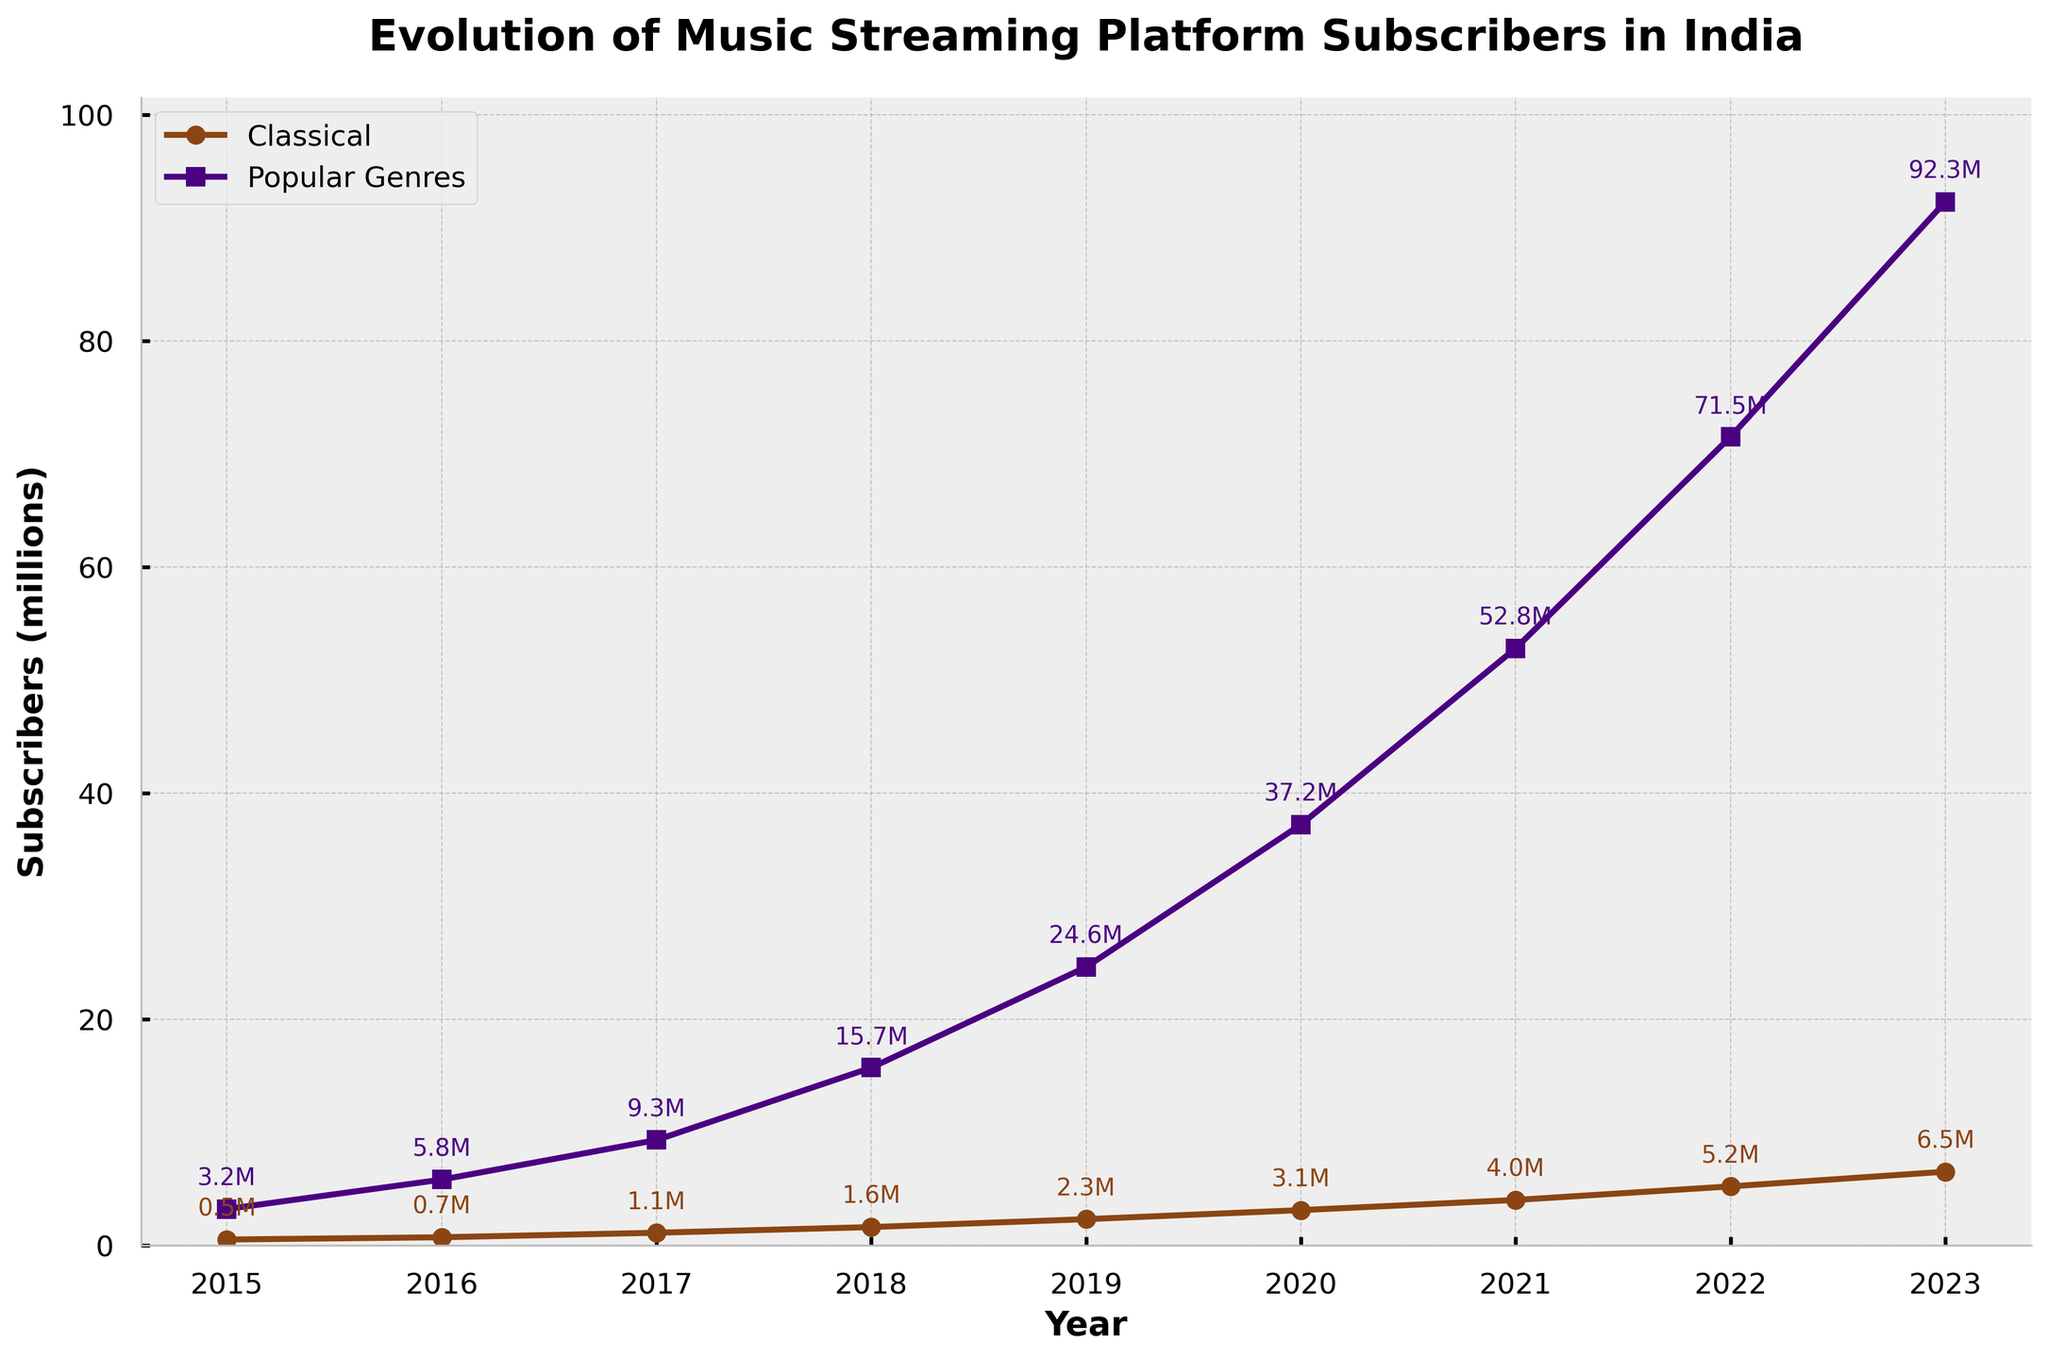What is the difference in the number of Classical subscribers between 2015 and 2023? The number of Classical subscribers in 2023 is 6.5 million, and in 2015, it is 0.5 million. The difference is calculated as 6.5 - 0.5 = 6 million.
Answer: 6 million How many total Popular Genres subscribers were there from 2015 to 2023? Add the subscribers for Popular Genres from 2015 to 2023: 3.2 + 5.8 + 9.3 + 15.7 + 24.6 + 37.2 + 52.8 + 71.5 + 92.3 = 312.4 million.
Answer: 312.4 million In which year did Popular Genres subscribers exceed 50 million? By observing the trend in the chart, Popular Genres subscribers exceed 50 million in the year 2021, as it jumps from 37.2 million in 2020 to 52.8 million in 2021.
Answer: 2021 In which year was the gap between Classical and Popular Genres subscribers the smallest? The gap is smallest when you compare each year's values. The smallest difference is in 2015, where the gap is 3.2 - 0.5 = 2.7 million.
Answer: 2015 Which genre had a higher growth rate from 2015 to 2023, and what is the growth factor for each? Growth factor for Classical: 2023 subscribers / 2015 subscribers = 6.5 / 0.5 = 13. Growth factor for Popular Genres: 2023 subscribers / 2015 subscribers = 92.3 / 3.2 ≈ 28.84. Thus, Popular Genres had a higher growth rate.
Answer: Popular Genres What is the average number of Classical subscribers over the period 2015 to 2023? Sum the Classical subscribers and divide by the number of years: (0.5 + 0.7 + 1.1 + 1.6 + 2.3 + 3.1 + 4.0 + 5.2 + 6.5) / 9 = 25.0 / 9 ≈ 2.78 million.
Answer: 2.78 million In which year did Classical subscribers exceed 3 million? By observing the chart, Classical subscribers first exceed 3 million in 2020, with a value of 3.1 million.
Answer: 2020 Compare the subscriber counts for Classical and Popular Genres in 2018. Which was higher and by how much? In 2018, Classical subscribers were 1.6 million, while Popular Genres subscribers were 15.7 million. The difference is 15.7 - 1.6 = 14.1 million, and Popular Genres had more subscribers.
Answer: Popular Genres by 14.1 million Which year saw the largest increase in Popular Genres subscribers from the previous year? By calculating the yearly differences for Popular Genres: 2016: 5.8 - 3.2 = 2.6; 2017: 9.3 - 5.8 = 3.5; 2018: 15.7 - 9.3 = 6.4; 2019: 24.6 - 15.7 = 8.9; 2020: 37.2 - 24.6 = 12.6; 2021: 52.8 - 37.2 = 15.6; 2022: 71.5 - 52.8 = 18.7; 2023: 92.3 - 71.5 = 20.8. The largest increase was from 2022 to 2023, which was 20.8 million.
Answer: 2023 How does the visual contrast of the different lines (Classical and Popular Genres) help in understanding the trends? The Classical line is plotted with a brownish color and round markers, while the Popular Genres line is purplish with square markers. These visual distinctions help clearly differentiate and follow the trends of each genre across the years.
Answer: Differentiation by color and markers 